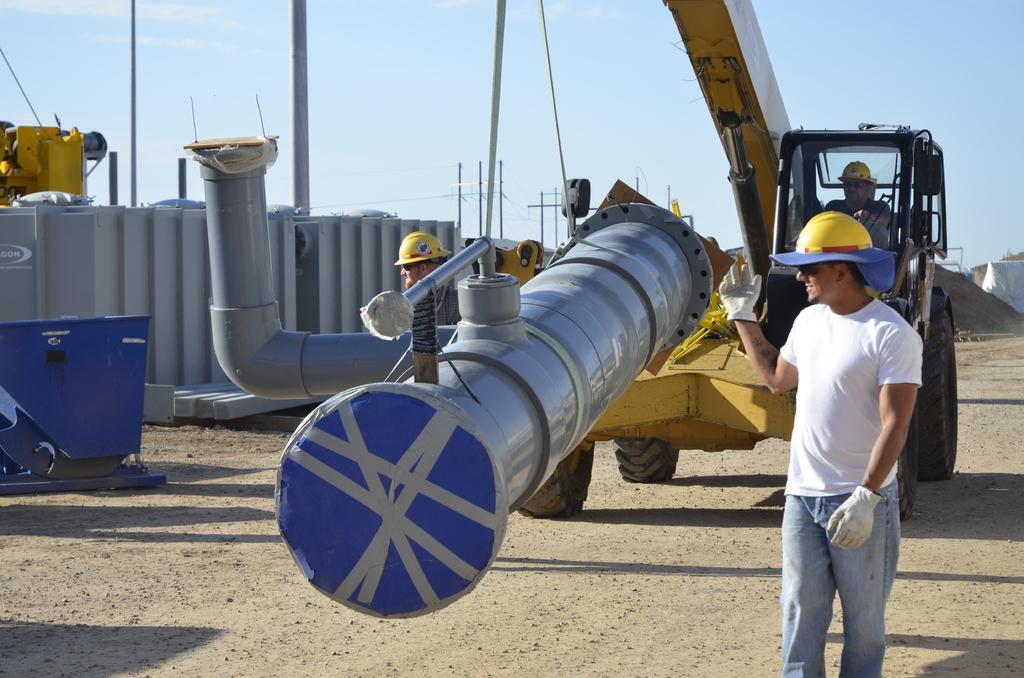Describe this image in one or two sentences. In this image I can see a person is driving a vehicle on the road and two persons. In the background I can see metal tanks, machines and the sky. This image is taken may be during a sunny day. 